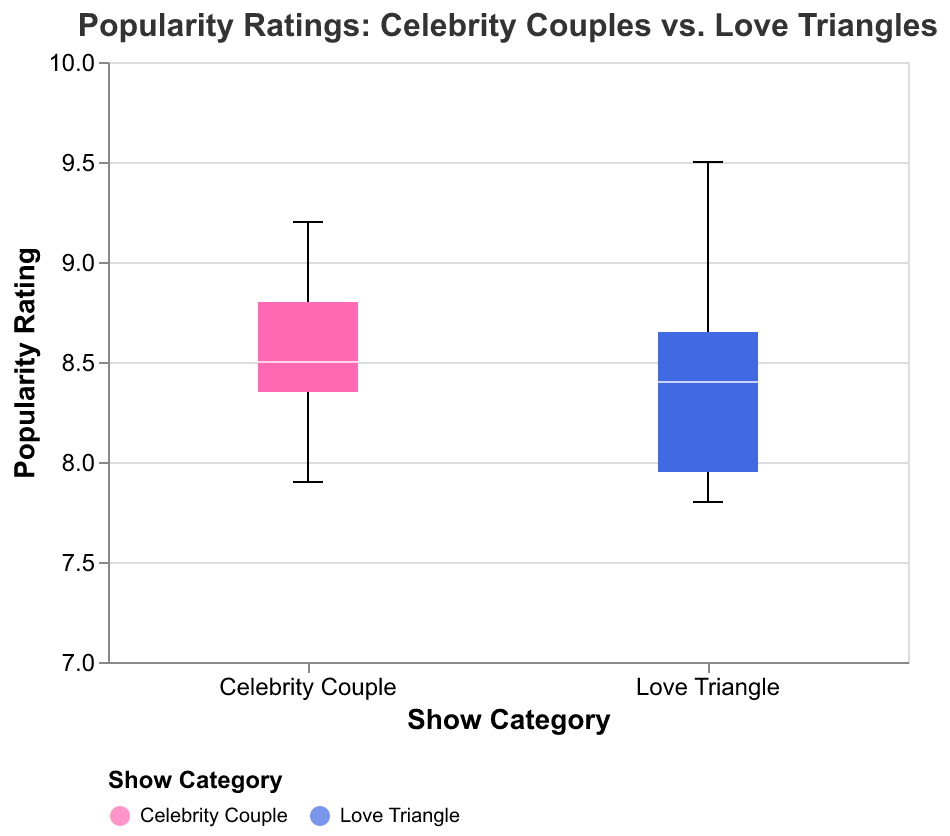What is the title of the plot? The title of the plot is placed at the top, clearly labeled for easy identification.
Answer: Popularity Ratings: Celebrity Couples vs. Love Triangles What do the two different colors in the box plot represent? The legend at the bottom of the plot explains that the two colors represent different show categories: one color for "Celebrity Couple" shows (pink) and another color for "Love Triangle" shows (blue).
Answer: Celebrity Couple and Love Triangle Which category has a higher median popularity rating? The white line within each box indicates the median popularity rating. By comparing the median lines, the "Celebrity Couple" category has a higher median.
Answer: Celebrity Couple What is the highest popularity rating for the "Love Triangle" category? The upper whisker of the "Love Triangle" box plot extends to the highest value in that category, which reaches 9.5.
Answer: 9.5 How many data points fall below the lower quartile for the "Celebrity Couple" category? Outliers are marked by small circles. For "Celebrity Couple", there is one such outlier below the lower quartile.
Answer: One What is the interquartile range (IQR) for the "Celebrity Couple" category? The IQR is the difference between the upper quartile and the lower quartile values. By examining the box for "Celebrity Couple", the upper quartile is around 8.7 and the lower quartile is around 8.3, so 8.7 - 8.3 = 0.4.
Answer: 0.4 Which show category has more outliers, and how many does it have? Small circles outside the whiskers signify outliers. The "Love Triangle" category has more outliers with two identified, while "Celebrity Couple" has one.
Answer: Love Triangle, Two What is the median popularity rating for "Love Triangle" shows? The white line inside the box for "Love Triangle" represents the median, which is identified at around 8.4.
Answer: 8.4 Which show category has a broader range of popularity ratings? The range is defined by the spread from the smallest to largest values (whiskers' extent). The "Love Triangle" category spans from about 7.8 to 9.5, whereas "Celebrity Couple" spans from about 7.9 to 9.2, making "Love Triangle" broader.
Answer: Love Triangle What can you say about the variance in popularity ratings between the two categories? Variance can be inferred by the spread of the boxes and whiskers. "Love Triangle" exhibits a broader spread, indicating higher variance. The box for "Celebrity Couple" is narrower, suggesting lower variance.
Answer: Love Triangle has higher variance 